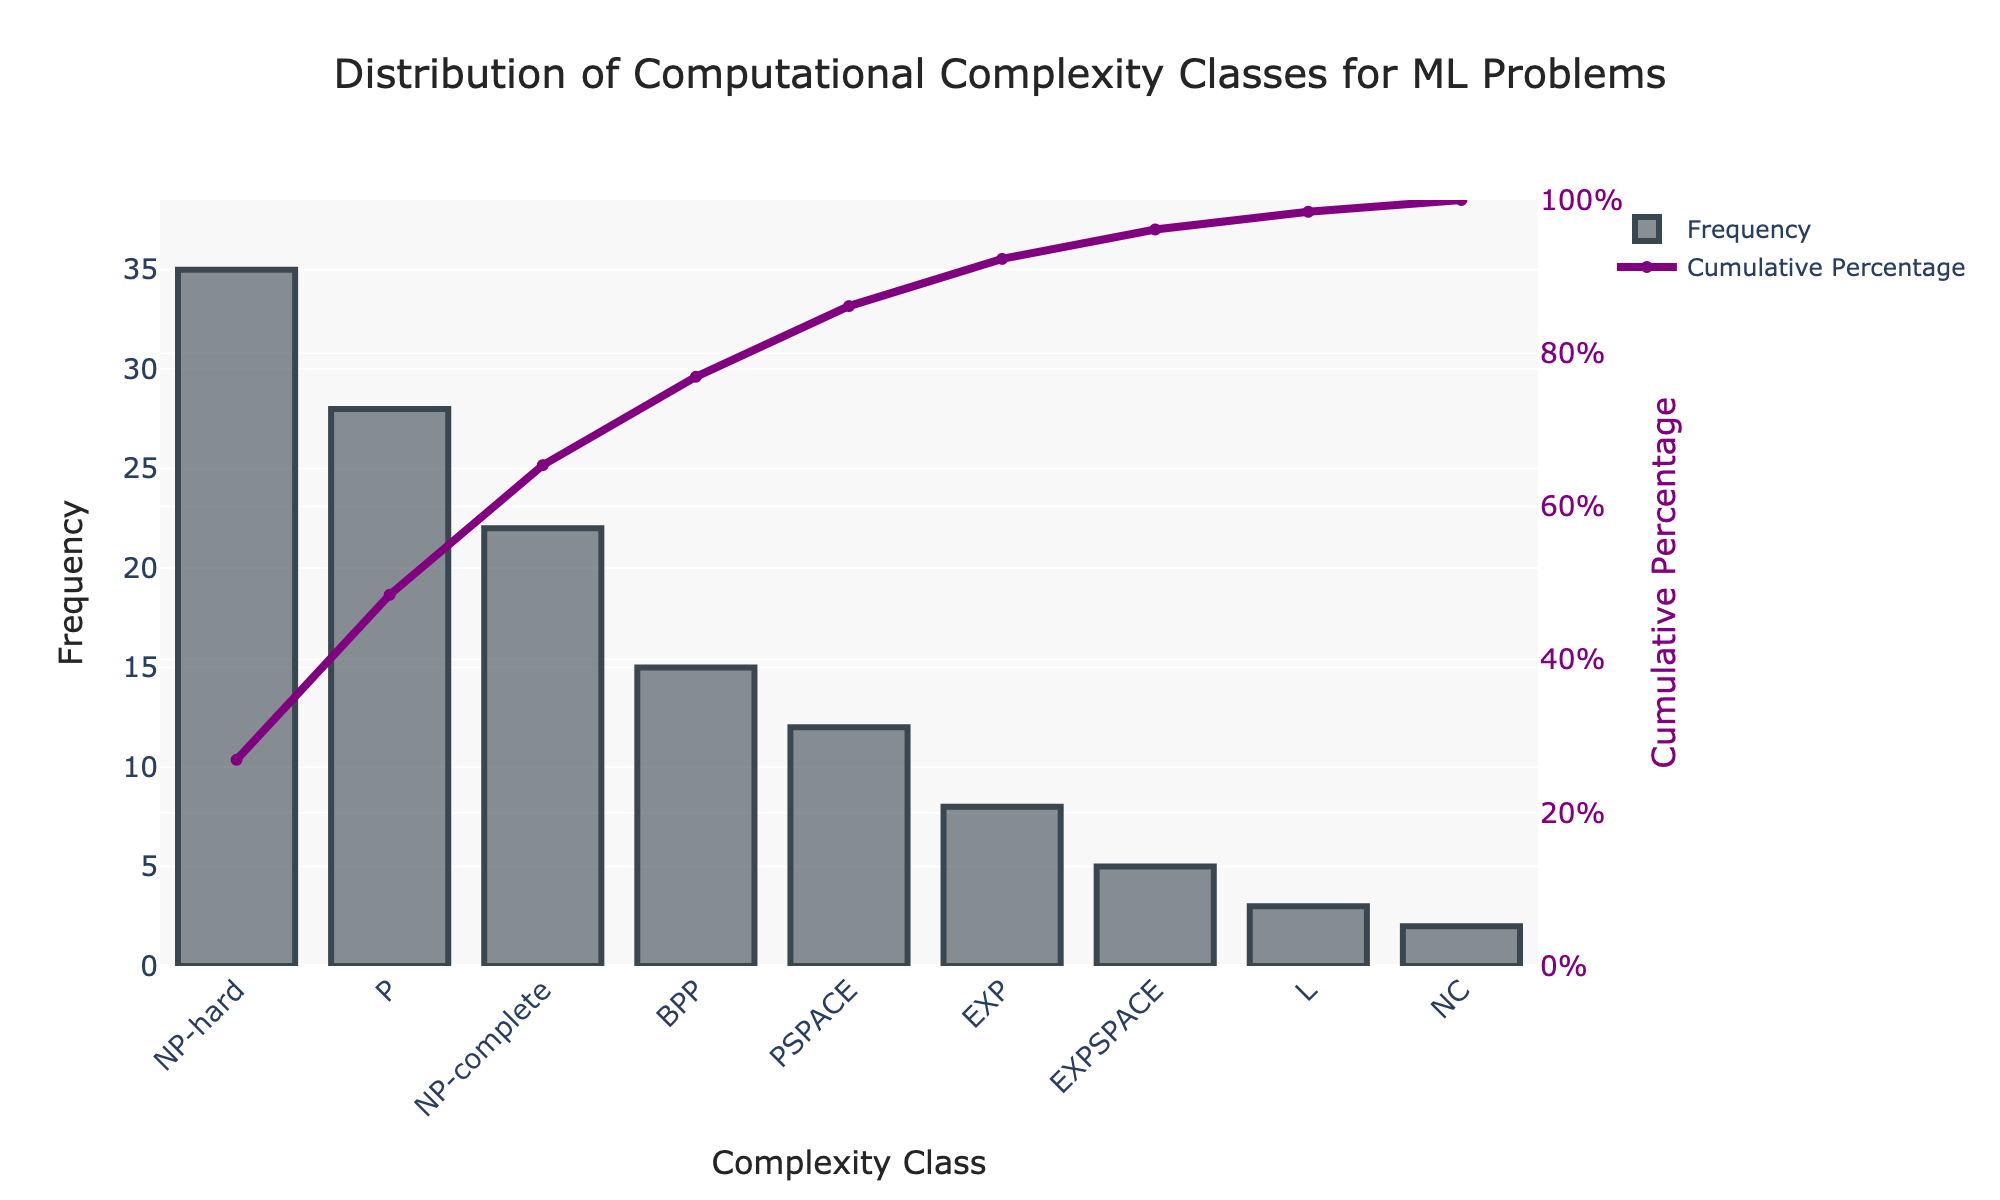What is the most frequent computational complexity class for ML problems? The Pareto chart shows that the bar with the highest frequency represents the NP-hard class.
Answer: NP-hard What is the title of the chart? The title of the chart is shown at the top center and reads "Distribution of Computational Complexity Classes for ML Problems."
Answer: Distribution of Computational Complexity Classes for ML Problems What percentage of ML problems fall under the NP-hard complexity class? The cumulative percentage line intersects with the NP-hard bar at around 25%.
Answer: Approximately 25% Which complexity classes make up the top 50% of the cumulative percentage? By looking at the cumulative percentage line, the top 50% includes NP-hard, P, and NP-complete classes.
Answer: NP-hard, P, NP-complete How does the frequency of NP-complete problems compare to L problems? The NP-complete bar is much taller than the L bar, indicating a higher frequency. Specifically, NP-complete has a frequency of 22, while L has a frequency of 3.
Answer: NP-complete is more frequent than L How many complexity classes have a frequency of less than 10? By counting the bars with frequencies under 10—specifically, EXP, EXPSPACE, L, and NC—we get 4 complexity classes.
Answer: 4 What is the cumulative percentage after including the P complexity class? The cumulative percentage line after the P bar reads approximately 55%.
Answer: Approximately 55% Which complexity class has the least frequency? The bar graph shows the shortest bar for the NC class, indicating that it has the least frequency.
Answer: NC How significantly does the frequency drop from the P class to the NP-complete class? The frequency drops from 28 for the P class to 22 for the NP-complete class, a difference of 6.
Answer: 6 What are the cumulative percentages before and after including the BPP complexity class? Before BPP, the cumulative percentage is approximately 75%, and after BPP, the figure shows it goes up to approximately 85%.
Answer: 75% before, 85% after 